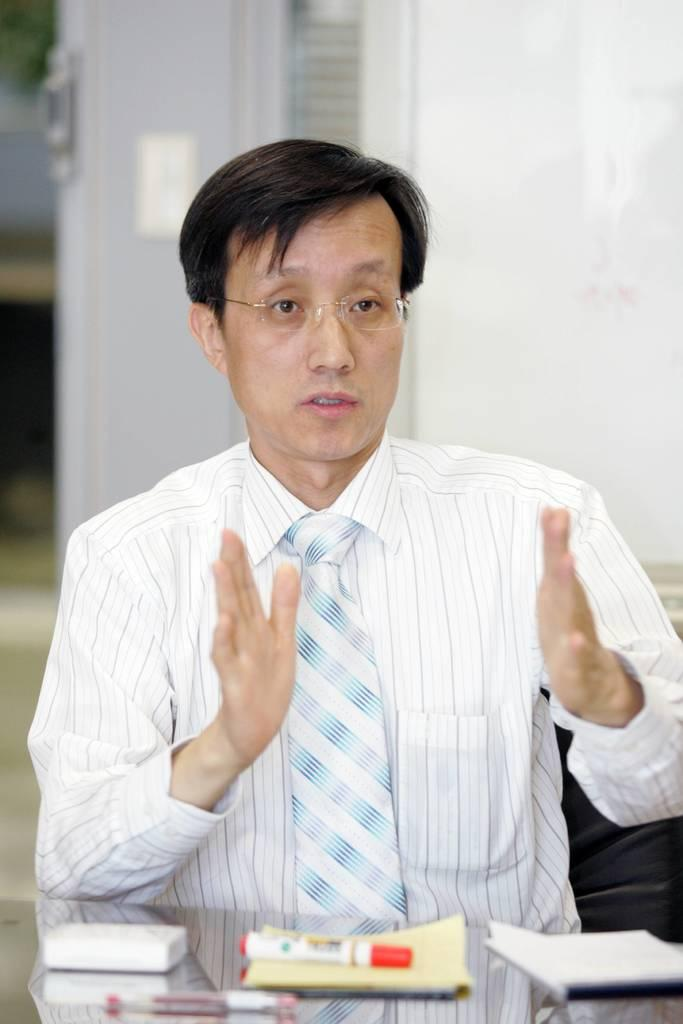What is the man in the image doing? The man is sitting in a chair and talking about something on the table. What objects can be seen on the table in the image? There are bookmarks, a napkin, and a pen on the table. Is there any other furniture or structure visible in the image? Yes, there is a door in the background of the image. How many rabbits can be seen playing with a soda can in the image? There are no rabbits or soda cans present in the image. What type of needle is being used by the man in the image? There is no needle visible in the image; the man is talking about something on the table. 